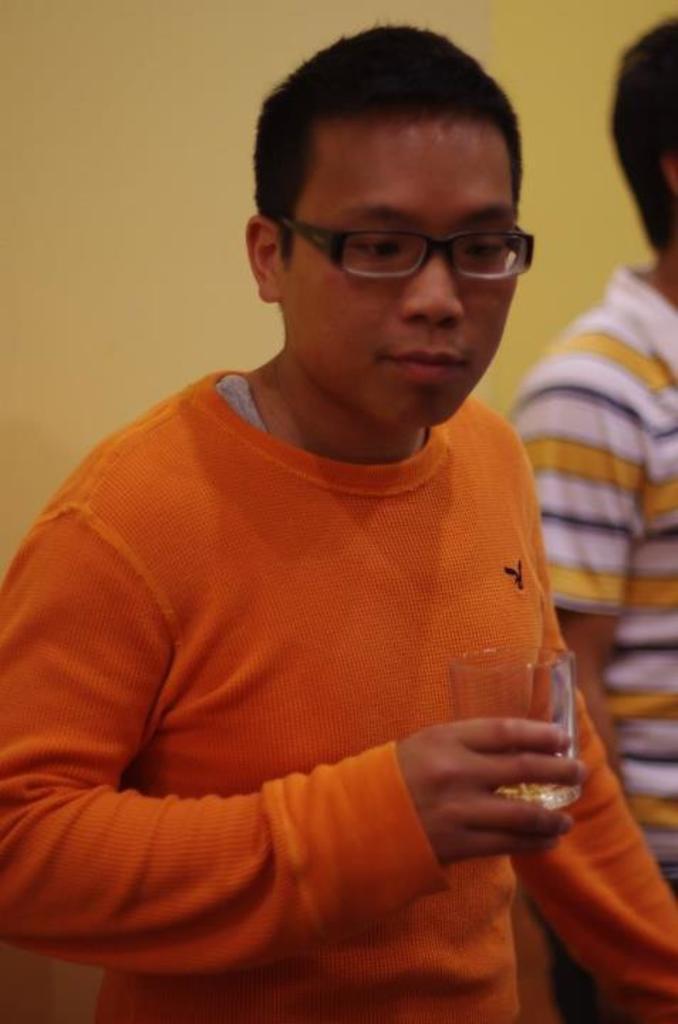Please provide a concise description of this image. In this picture there is a boy wearing orange color t-shirt and holding the glass in the hand and looking down. Behind there is a yellow color wall. 